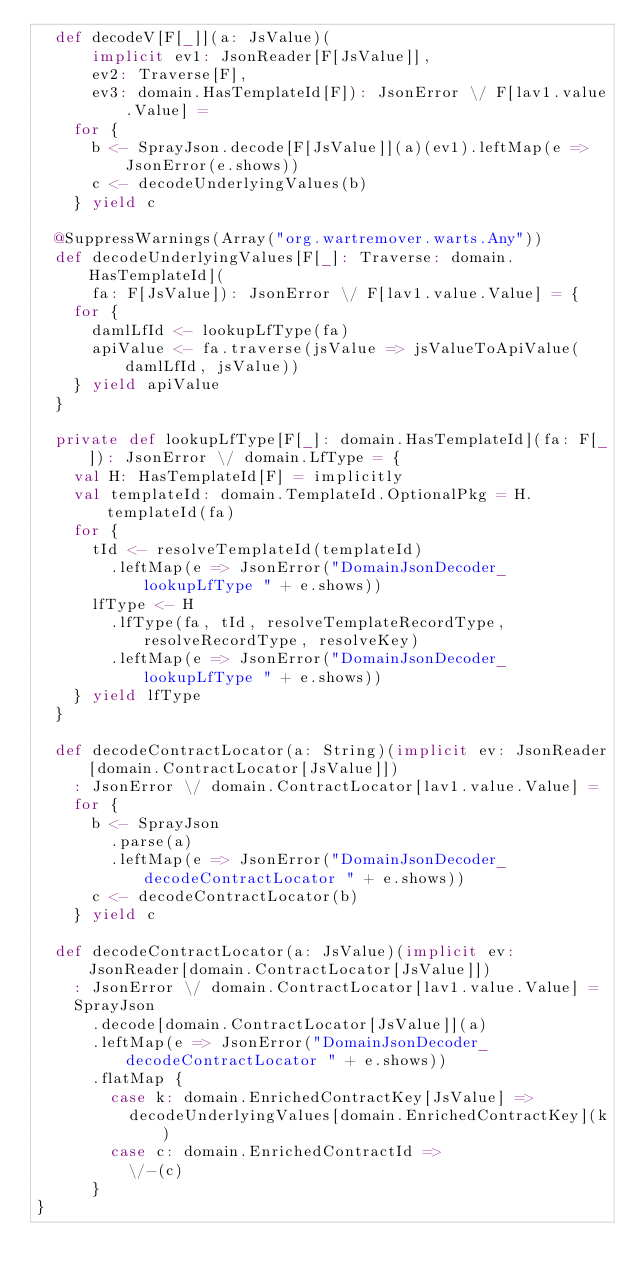Convert code to text. <code><loc_0><loc_0><loc_500><loc_500><_Scala_>  def decodeV[F[_]](a: JsValue)(
      implicit ev1: JsonReader[F[JsValue]],
      ev2: Traverse[F],
      ev3: domain.HasTemplateId[F]): JsonError \/ F[lav1.value.Value] =
    for {
      b <- SprayJson.decode[F[JsValue]](a)(ev1).leftMap(e => JsonError(e.shows))
      c <- decodeUnderlyingValues(b)
    } yield c

  @SuppressWarnings(Array("org.wartremover.warts.Any"))
  def decodeUnderlyingValues[F[_]: Traverse: domain.HasTemplateId](
      fa: F[JsValue]): JsonError \/ F[lav1.value.Value] = {
    for {
      damlLfId <- lookupLfType(fa)
      apiValue <- fa.traverse(jsValue => jsValueToApiValue(damlLfId, jsValue))
    } yield apiValue
  }

  private def lookupLfType[F[_]: domain.HasTemplateId](fa: F[_]): JsonError \/ domain.LfType = {
    val H: HasTemplateId[F] = implicitly
    val templateId: domain.TemplateId.OptionalPkg = H.templateId(fa)
    for {
      tId <- resolveTemplateId(templateId)
        .leftMap(e => JsonError("DomainJsonDecoder_lookupLfType " + e.shows))
      lfType <- H
        .lfType(fa, tId, resolveTemplateRecordType, resolveRecordType, resolveKey)
        .leftMap(e => JsonError("DomainJsonDecoder_lookupLfType " + e.shows))
    } yield lfType
  }

  def decodeContractLocator(a: String)(implicit ev: JsonReader[domain.ContractLocator[JsValue]])
    : JsonError \/ domain.ContractLocator[lav1.value.Value] =
    for {
      b <- SprayJson
        .parse(a)
        .leftMap(e => JsonError("DomainJsonDecoder_decodeContractLocator " + e.shows))
      c <- decodeContractLocator(b)
    } yield c

  def decodeContractLocator(a: JsValue)(implicit ev: JsonReader[domain.ContractLocator[JsValue]])
    : JsonError \/ domain.ContractLocator[lav1.value.Value] =
    SprayJson
      .decode[domain.ContractLocator[JsValue]](a)
      .leftMap(e => JsonError("DomainJsonDecoder_decodeContractLocator " + e.shows))
      .flatMap {
        case k: domain.EnrichedContractKey[JsValue] =>
          decodeUnderlyingValues[domain.EnrichedContractKey](k)
        case c: domain.EnrichedContractId =>
          \/-(c)
      }
}
</code> 